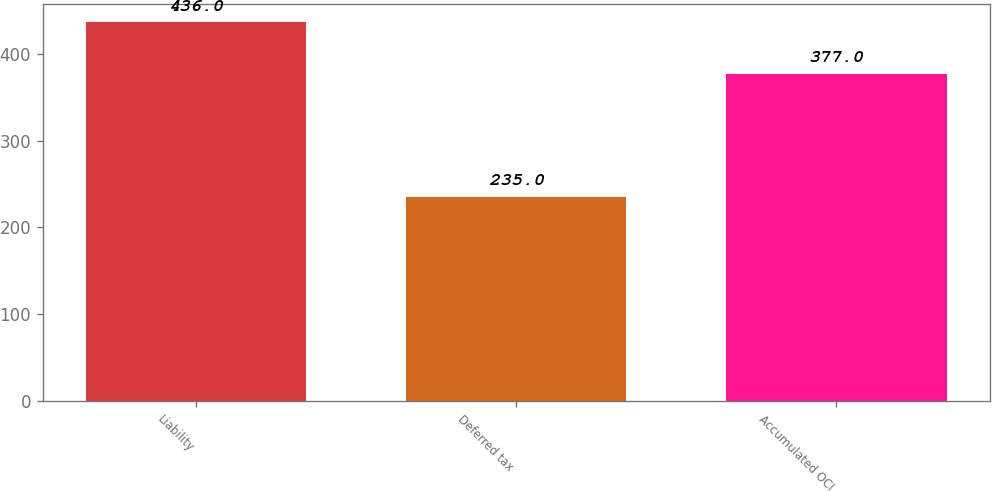Convert chart. <chart><loc_0><loc_0><loc_500><loc_500><bar_chart><fcel>Liability<fcel>Deferred tax<fcel>Accumulated OCI<nl><fcel>436<fcel>235<fcel>377<nl></chart> 